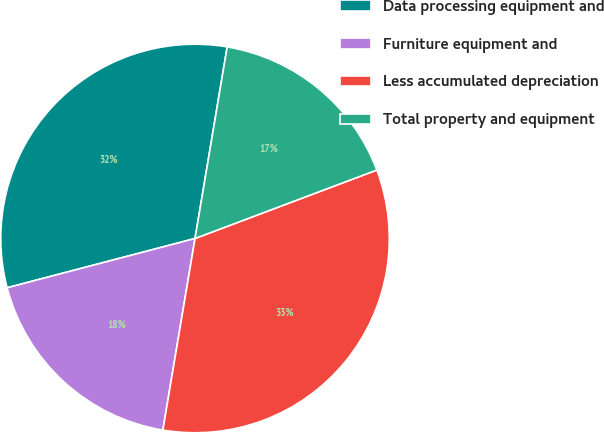Convert chart to OTSL. <chart><loc_0><loc_0><loc_500><loc_500><pie_chart><fcel>Data processing equipment and<fcel>Furniture equipment and<fcel>Less accumulated depreciation<fcel>Total property and equipment<nl><fcel>31.73%<fcel>18.27%<fcel>33.38%<fcel>16.62%<nl></chart> 